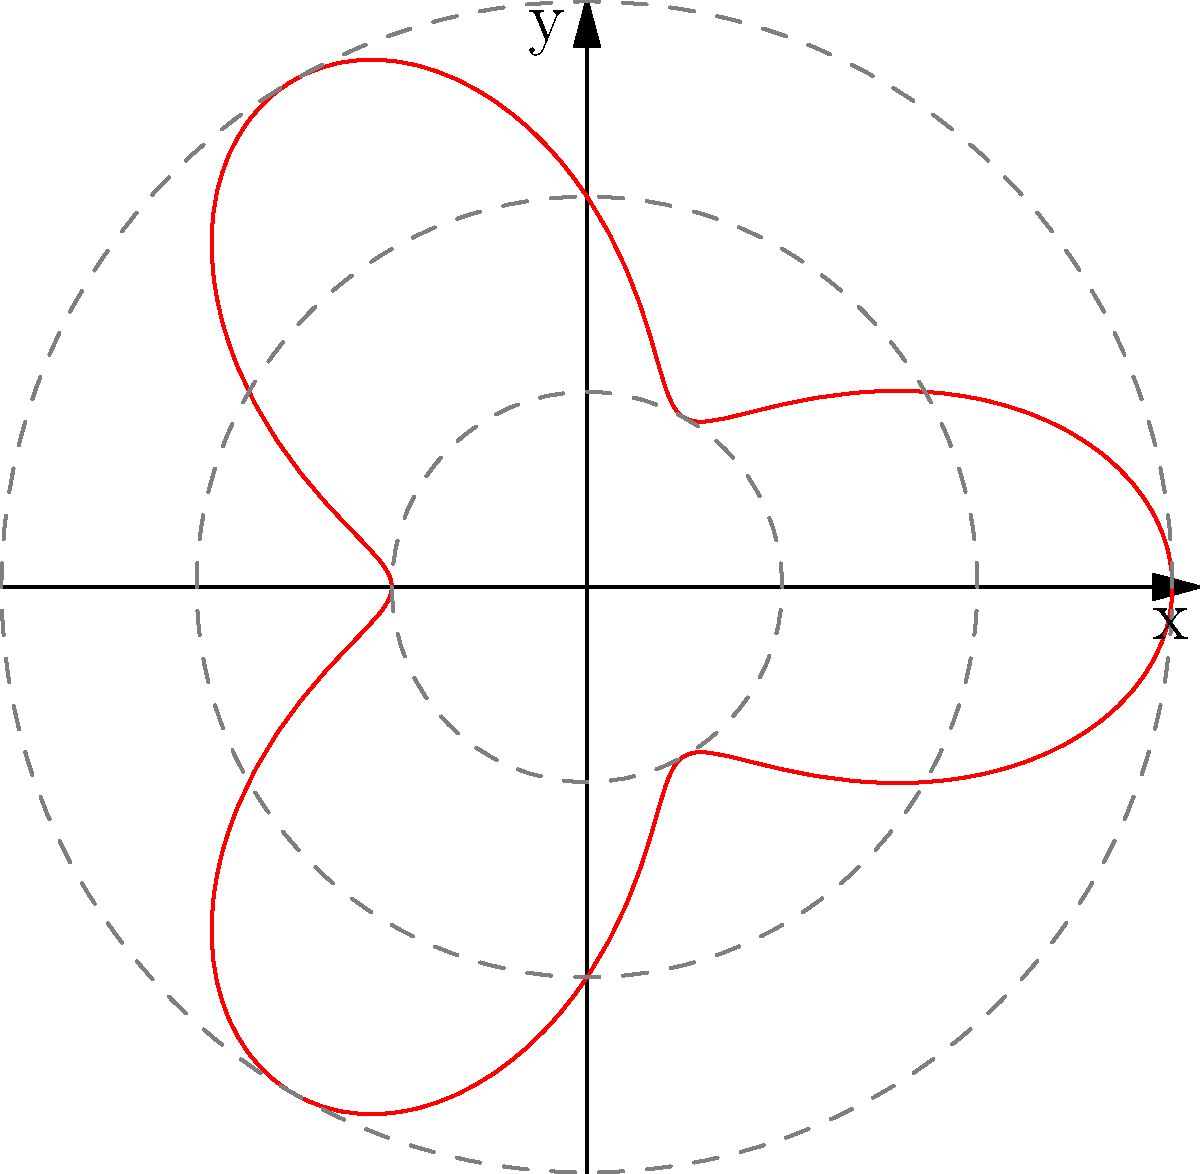In the latest G.I. Joe comic, the Skystriker jet performs a unique maneuver. Its trajectory in polar coordinates is given by the equation $r = 2 + \cos(3\theta)$. What is the maximum distance the Skystriker reaches from the origin during this maneuver? To find the maximum distance from the origin, we need to follow these steps:

1) The distance from the origin in polar coordinates is given by $r$.

2) In this case, $r = 2 + \cos(3\theta)$.

3) The maximum value of $\cos(3\theta)$ is 1, which occurs when $3\theta = 0, 2\pi, 4\pi,$ etc.

4) The minimum value of $\cos(3\theta)$ is -1.

5) Therefore, the maximum value of $r$ occurs when $\cos(3\theta) = 1$.

6) Substituting this into the equation:

   $r_{max} = 2 + 1 = 3$

7) Thus, the maximum distance the Skystriker reaches from the origin is 3 units.
Answer: 3 units 